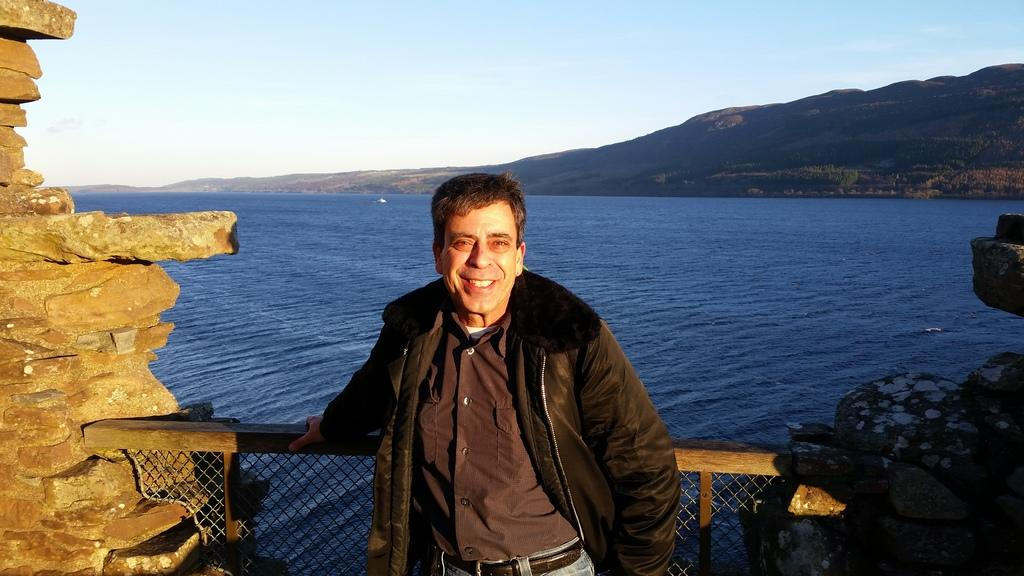Who is the main subject in the image? There is an old man in the image. What is the old man wearing? The old man is wearing a brown shirt and jacket. Where is the old man standing? The old man is standing in front of a fence. What is behind the fence? There are two walls in front of the old man. What can be seen beyond the walls? The old man is standing in front of an ocean. What is visible in the distance behind the ocean? There are mountains visible behind the ocean. What is visible above the ocean? The sky is visible above the ocean. What type of insect can be seen flying around the old man's head in the image? There is no insect visible around the old man's head in the image. 